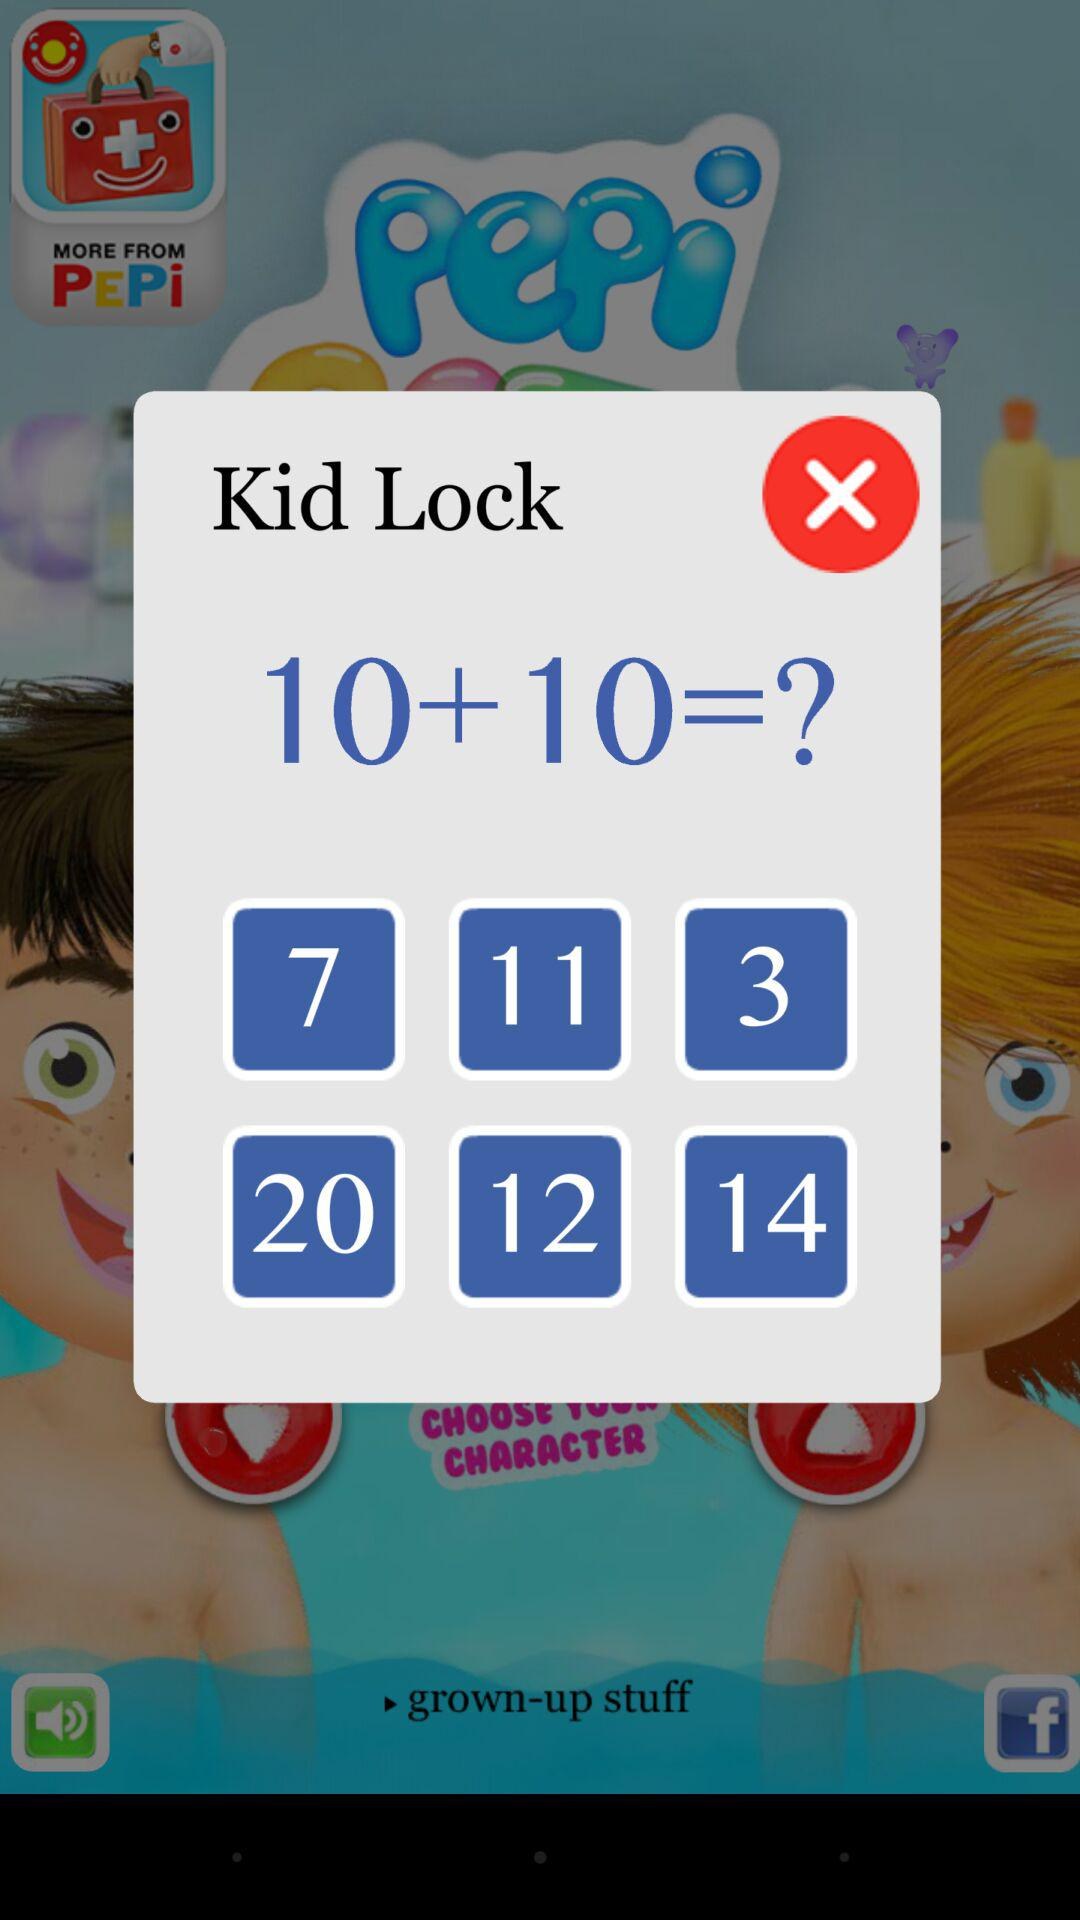What is the sum of the two numbers in the math problem?
Answer the question using a single word or phrase. 20 